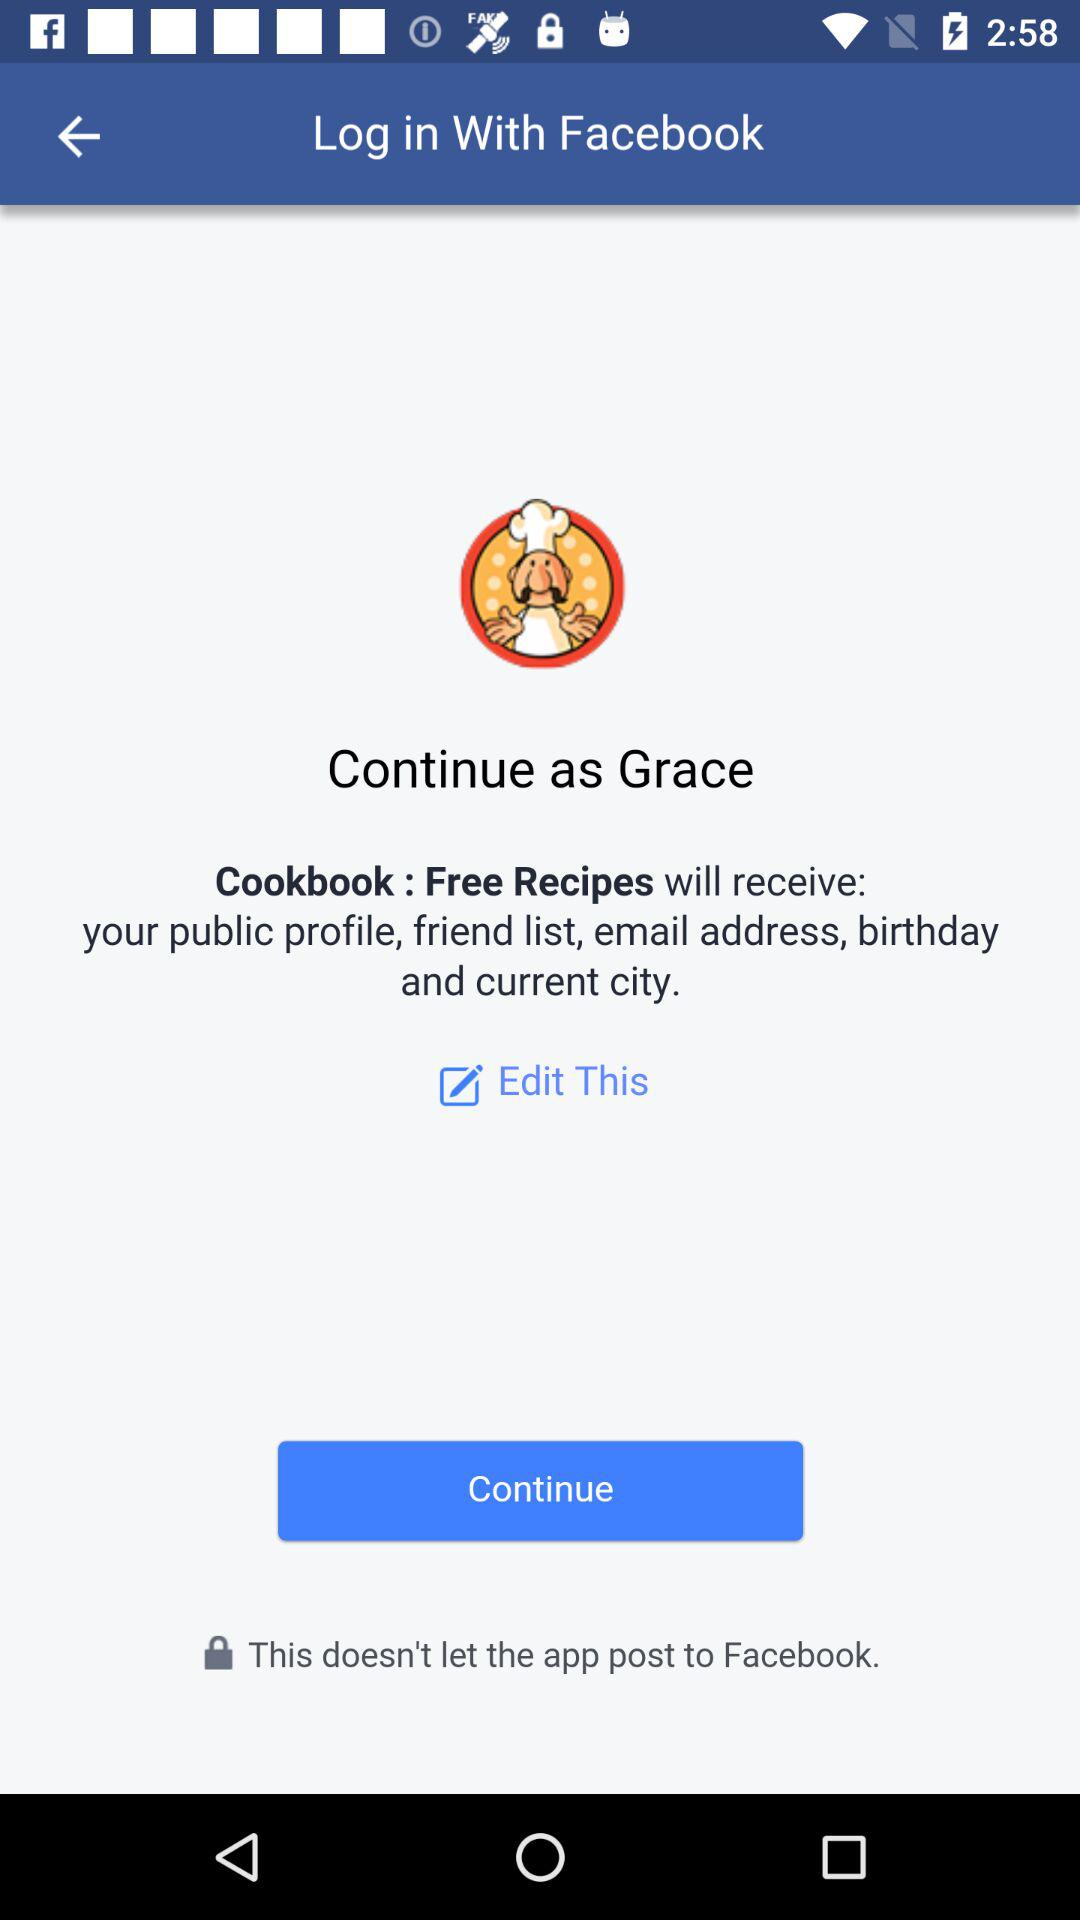What is the name of the user who can continue the application? The name of the user is Grace. 